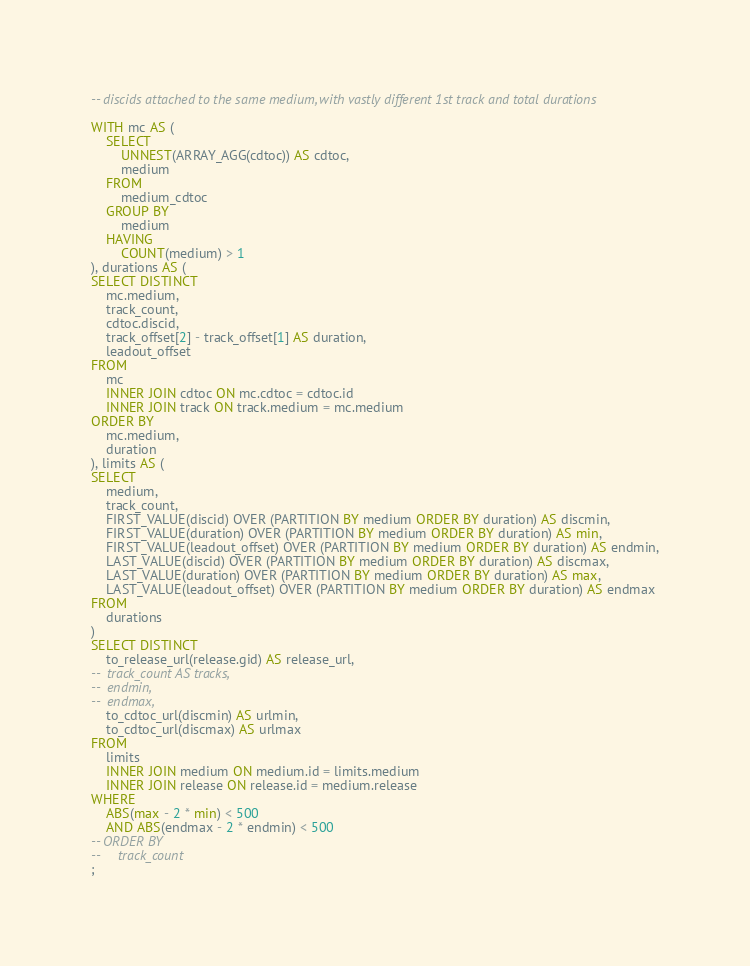Convert code to text. <code><loc_0><loc_0><loc_500><loc_500><_SQL_>-- discids attached to the same medium, with vastly different 1st track and total durations

WITH mc AS (
    SELECT
        UNNEST(ARRAY_AGG(cdtoc)) AS cdtoc,
        medium
    FROM
        medium_cdtoc
    GROUP BY
        medium
    HAVING
        COUNT(medium) > 1
), durations AS (
SELECT DISTINCT
    mc.medium,
    track_count,
    cdtoc.discid,
    track_offset[2] - track_offset[1] AS duration,
    leadout_offset
FROM
    mc
    INNER JOIN cdtoc ON mc.cdtoc = cdtoc.id
    INNER JOIN track ON track.medium = mc.medium
ORDER BY
    mc.medium,
    duration
), limits AS (
SELECT
    medium,
    track_count,
    FIRST_VALUE(discid) OVER (PARTITION BY medium ORDER BY duration) AS discmin,
    FIRST_VALUE(duration) OVER (PARTITION BY medium ORDER BY duration) AS min,
    FIRST_VALUE(leadout_offset) OVER (PARTITION BY medium ORDER BY duration) AS endmin,
    LAST_VALUE(discid) OVER (PARTITION BY medium ORDER BY duration) AS discmax,
    LAST_VALUE(duration) OVER (PARTITION BY medium ORDER BY duration) AS max,
    LAST_VALUE(leadout_offset) OVER (PARTITION BY medium ORDER BY duration) AS endmax
FROM
    durations
)
SELECT DISTINCT
    to_release_url(release.gid) AS release_url,
--  track_count AS tracks,
--  endmin,
--  endmax,
    to_cdtoc_url(discmin) AS urlmin,
    to_cdtoc_url(discmax) AS urlmax
FROM
    limits
    INNER JOIN medium ON medium.id = limits.medium
    INNER JOIN release ON release.id = medium.release
WHERE
    ABS(max - 2 * min) < 500
    AND ABS(endmax - 2 * endmin) < 500
-- ORDER BY
--     track_count
;
</code> 